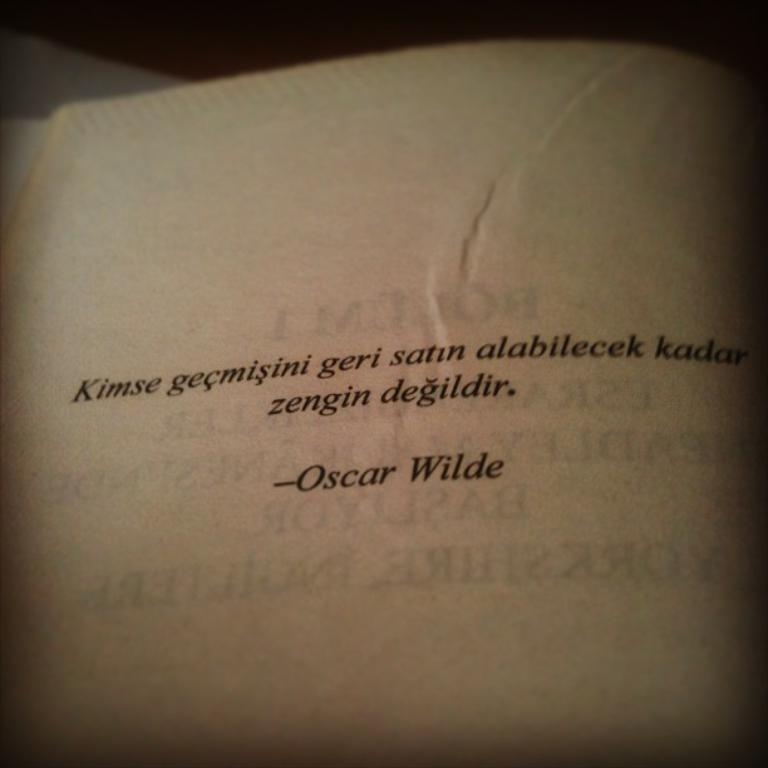<image>
Write a terse but informative summary of the picture. A quote on the page of a book in German from Oscar WIlde. 